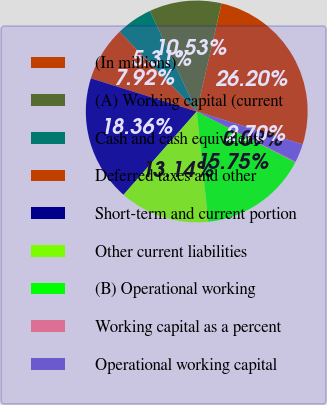Convert chart. <chart><loc_0><loc_0><loc_500><loc_500><pie_chart><fcel>(In millions)<fcel>(A) Working capital (current<fcel>Cash and cash equivalents<fcel>Deferred taxes and other<fcel>Short-term and current portion<fcel>Other current liabilities<fcel>(B) Operational working<fcel>Working capital as a percent<fcel>Operational working capital<nl><fcel>26.2%<fcel>10.53%<fcel>5.31%<fcel>7.92%<fcel>18.36%<fcel>13.14%<fcel>15.75%<fcel>0.09%<fcel>2.7%<nl></chart> 